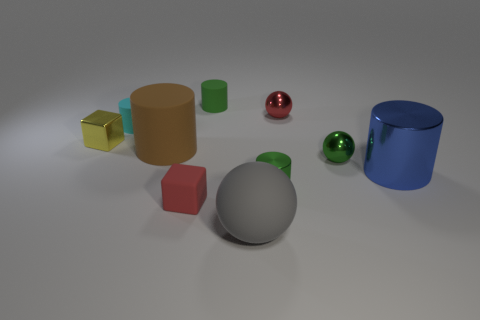Subtract all large cylinders. How many cylinders are left? 3 Subtract all cyan blocks. How many green cylinders are left? 2 Subtract all red balls. How many balls are left? 2 Subtract all balls. How many objects are left? 7 Subtract 2 cubes. How many cubes are left? 0 Add 1 tiny green matte cylinders. How many tiny green matte cylinders are left? 2 Add 7 metal cylinders. How many metal cylinders exist? 9 Subtract 1 red balls. How many objects are left? 9 Subtract all green blocks. Subtract all green spheres. How many blocks are left? 2 Subtract all gray spheres. Subtract all large gray rubber spheres. How many objects are left? 8 